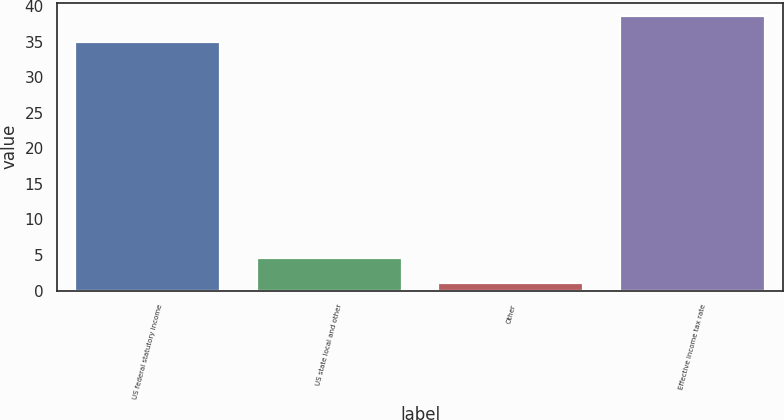<chart> <loc_0><loc_0><loc_500><loc_500><bar_chart><fcel>US federal statutory income<fcel>US state local and other<fcel>Other<fcel>Effective income tax rate<nl><fcel>35<fcel>4.63<fcel>1.1<fcel>38.53<nl></chart> 